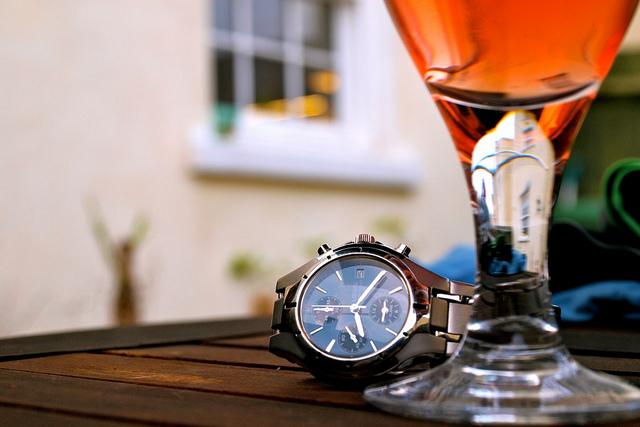What time is it?
Concise answer only. 8:20. What color is the drink?
Answer briefly. Red. What is the yellow object in the window?
Keep it brief. Light. 